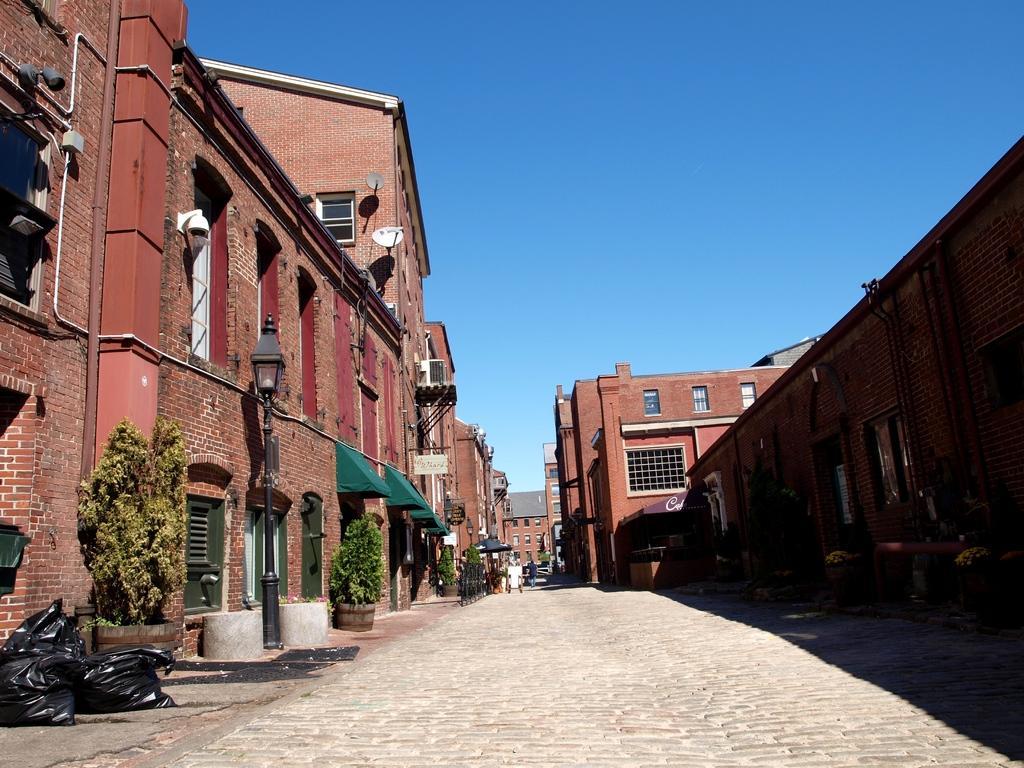Can you describe this image briefly? In this image we can see few buildings with doors and windows and there are some potted plants and we can see a street light and there are few black color bags on the left side of the image and we can see the sky at the top. 